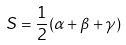<formula> <loc_0><loc_0><loc_500><loc_500>S = \frac { 1 } { 2 } ( \alpha + \beta + \gamma )</formula> 